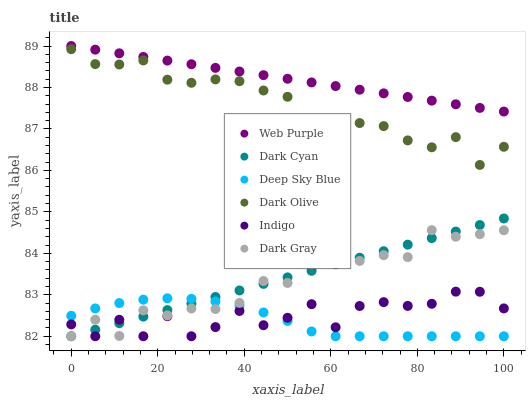Does Deep Sky Blue have the minimum area under the curve?
Answer yes or no. Yes. Does Web Purple have the maximum area under the curve?
Answer yes or no. Yes. Does Dark Olive have the minimum area under the curve?
Answer yes or no. No. Does Dark Olive have the maximum area under the curve?
Answer yes or no. No. Is Dark Cyan the smoothest?
Answer yes or no. Yes. Is Indigo the roughest?
Answer yes or no. Yes. Is Dark Olive the smoothest?
Answer yes or no. No. Is Dark Olive the roughest?
Answer yes or no. No. Does Indigo have the lowest value?
Answer yes or no. Yes. Does Dark Olive have the lowest value?
Answer yes or no. No. Does Web Purple have the highest value?
Answer yes or no. Yes. Does Dark Olive have the highest value?
Answer yes or no. No. Is Dark Gray less than Dark Olive?
Answer yes or no. Yes. Is Web Purple greater than Dark Cyan?
Answer yes or no. Yes. Does Deep Sky Blue intersect Dark Cyan?
Answer yes or no. Yes. Is Deep Sky Blue less than Dark Cyan?
Answer yes or no. No. Is Deep Sky Blue greater than Dark Cyan?
Answer yes or no. No. Does Dark Gray intersect Dark Olive?
Answer yes or no. No. 